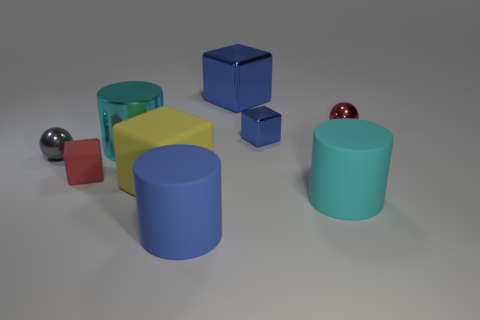What number of other objects are there of the same material as the small blue thing?
Ensure brevity in your answer.  4. There is a red object in front of the big cyan metallic thing; does it have the same shape as the small gray metallic thing that is in front of the big blue metallic cube?
Keep it short and to the point. No. There is a matte object in front of the large cyan object that is right of the object in front of the large cyan matte cylinder; what is its color?
Make the answer very short. Blue. What number of other objects are the same color as the large metallic cube?
Give a very brief answer. 2. Are there fewer large cyan shiny objects than metal objects?
Your response must be concise. Yes. The object that is in front of the large yellow matte object and right of the big blue shiny block is what color?
Your answer should be very brief. Cyan. What material is the small blue thing that is the same shape as the large yellow rubber object?
Your answer should be very brief. Metal. Are there any other things that have the same size as the gray shiny thing?
Provide a short and direct response. Yes. Is the number of big blue shiny objects greater than the number of large cylinders?
Offer a very short reply. No. What size is the thing that is both on the left side of the big blue shiny block and in front of the yellow object?
Your answer should be compact. Large. 